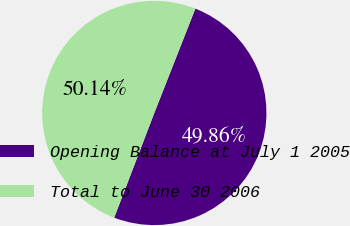<chart> <loc_0><loc_0><loc_500><loc_500><pie_chart><fcel>Opening Balance at July 1 2005<fcel>Total to June 30 2006<nl><fcel>49.86%<fcel>50.14%<nl></chart> 